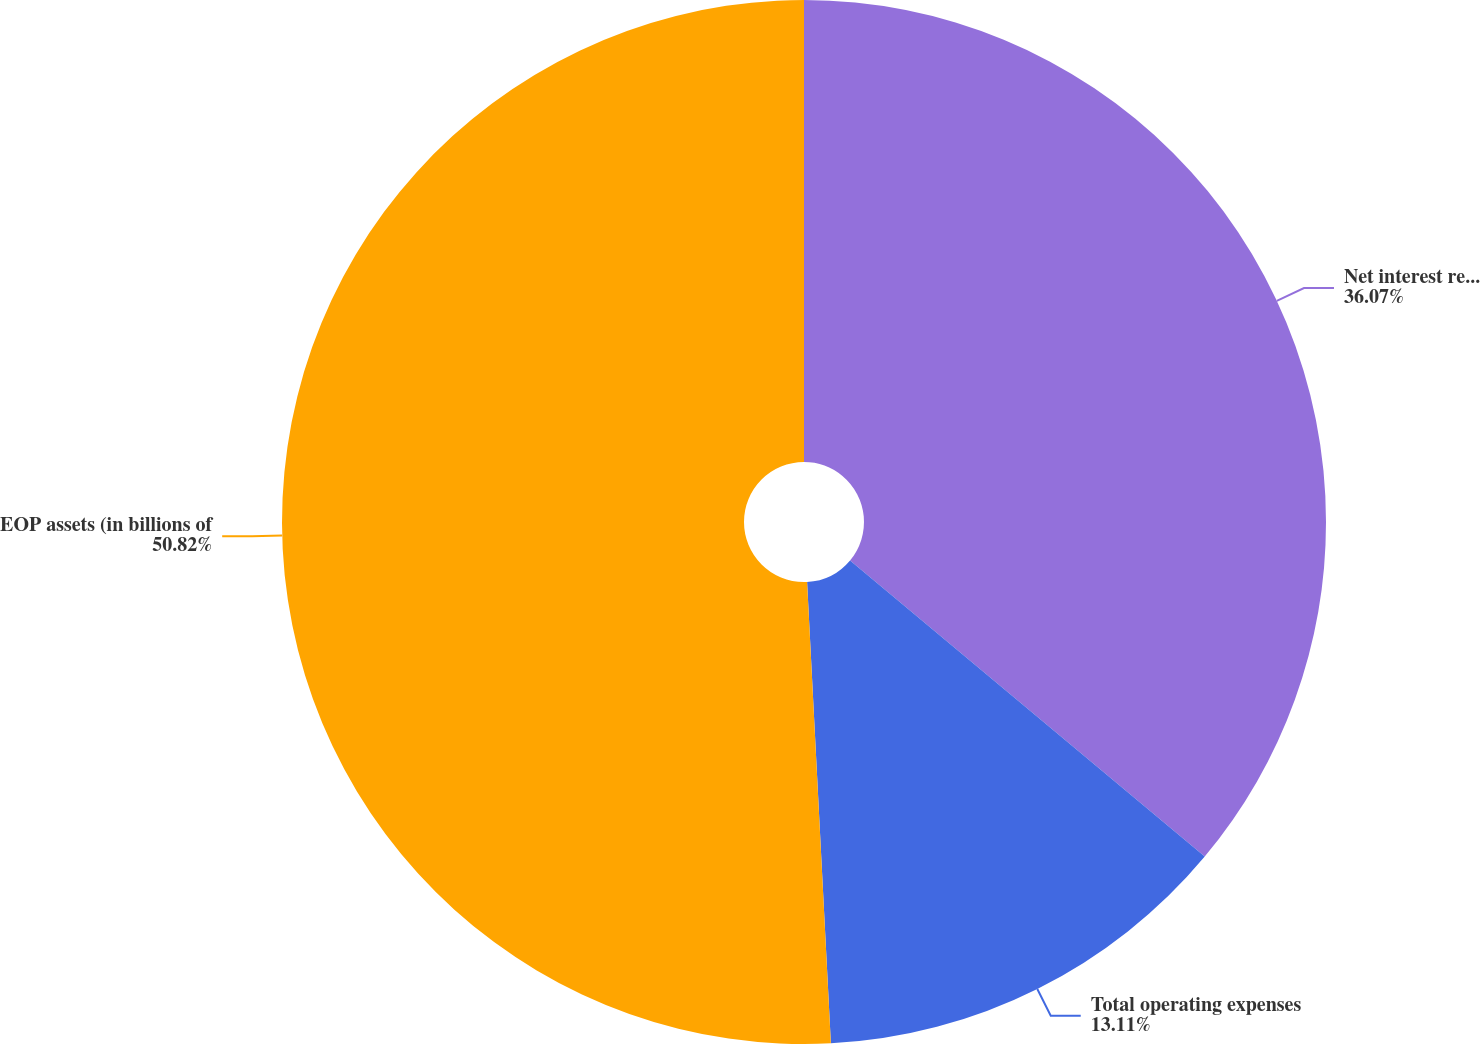<chart> <loc_0><loc_0><loc_500><loc_500><pie_chart><fcel>Net interest revenue<fcel>Total operating expenses<fcel>EOP assets (in billions of<nl><fcel>36.07%<fcel>13.11%<fcel>50.82%<nl></chart> 